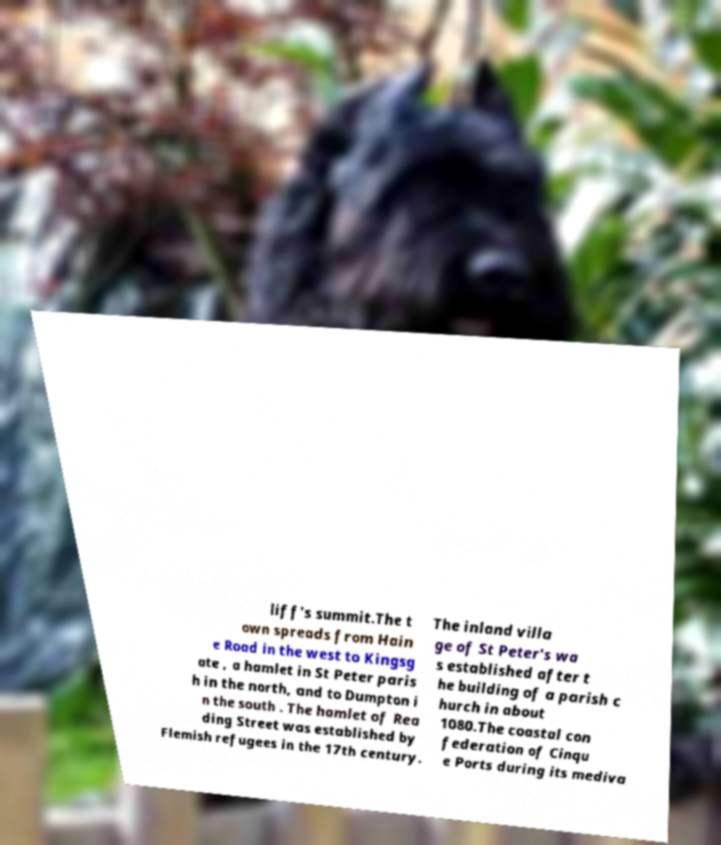Can you read and provide the text displayed in the image?This photo seems to have some interesting text. Can you extract and type it out for me? liff's summit.The t own spreads from Hain e Road in the west to Kingsg ate , a hamlet in St Peter paris h in the north, and to Dumpton i n the south . The hamlet of Rea ding Street was established by Flemish refugees in the 17th century. The inland villa ge of St Peter's wa s established after t he building of a parish c hurch in about 1080.The coastal con federation of Cinqu e Ports during its mediva 